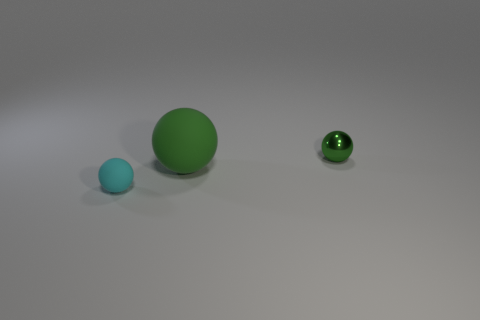Are there any other things that have the same size as the green rubber thing?
Your answer should be very brief. No. Is there anything else that has the same material as the tiny green ball?
Offer a terse response. No. Do the metallic sphere and the large object have the same color?
Your answer should be very brief. Yes. Are there any other big green matte things that have the same shape as the big green object?
Provide a succinct answer. No. How many other objects are the same color as the small shiny sphere?
Offer a very short reply. 1. What is the color of the small thing that is behind the ball left of the green object in front of the tiny metallic object?
Your answer should be compact. Green. Is the number of green things that are in front of the small metal sphere the same as the number of green rubber balls?
Your answer should be compact. Yes. Does the rubber ball behind the cyan thing have the same size as the tiny shiny object?
Your answer should be very brief. No. What number of tiny matte spheres are there?
Offer a very short reply. 1. What number of things are both in front of the green metallic sphere and behind the large green matte object?
Your response must be concise. 0. 